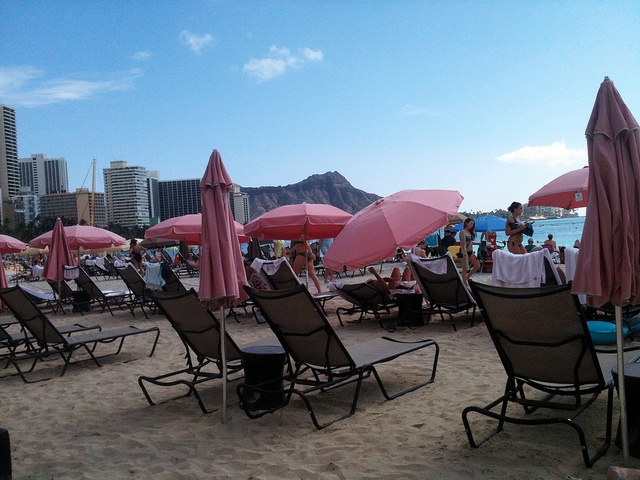Describe the objects in this image and their specific colors. I can see chair in gray and black tones, chair in gray and black tones, umbrella in gray, black, and purple tones, umbrella in gray, brown, and lightpink tones, and umbrella in gray, maroon, purple, and black tones in this image. 